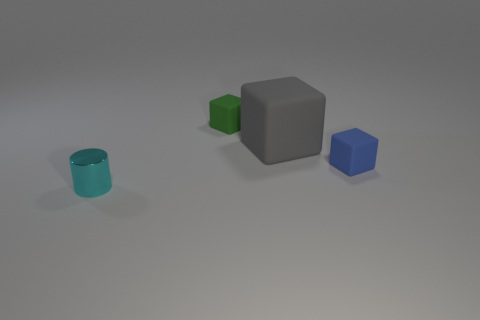Add 4 rubber blocks. How many objects exist? 8 Subtract all blocks. How many objects are left? 1 Subtract 0 red balls. How many objects are left? 4 Subtract all tiny blue matte blocks. Subtract all tiny blue cubes. How many objects are left? 2 Add 4 gray cubes. How many gray cubes are left? 5 Add 4 large purple shiny cubes. How many large purple shiny cubes exist? 4 